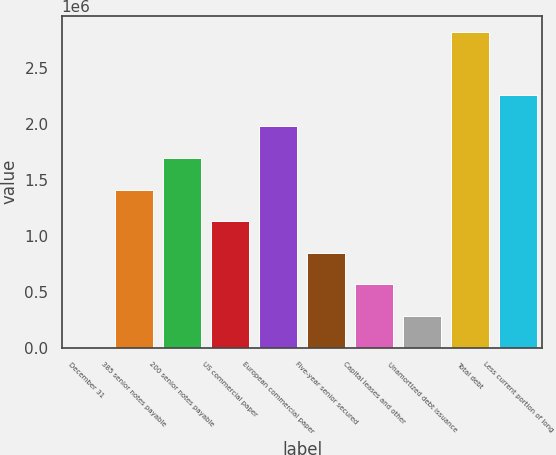Convert chart. <chart><loc_0><loc_0><loc_500><loc_500><bar_chart><fcel>December 31<fcel>385 senior notes payable<fcel>200 senior notes payable<fcel>US commercial paper<fcel>European commercial paper<fcel>Five-year senior secured<fcel>Capital leases and other<fcel>Unamortized debt issuance<fcel>Total debt<fcel>Less current portion of long<nl><fcel>2017<fcel>1.4116e+06<fcel>1.69351e+06<fcel>1.12968e+06<fcel>1.97543e+06<fcel>847765<fcel>565849<fcel>283933<fcel>2.82118e+06<fcel>2.25734e+06<nl></chart> 